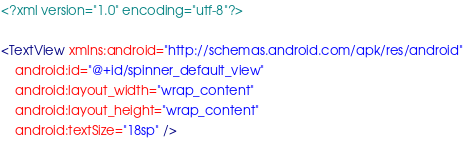Convert code to text. <code><loc_0><loc_0><loc_500><loc_500><_XML_><?xml version="1.0" encoding="utf-8"?>

<TextView xmlns:android="http://schemas.android.com/apk/res/android"
    android:id="@+id/spinner_default_view"
    android:layout_width="wrap_content"
    android:layout_height="wrap_content"
    android:textSize="18sp" /></code> 